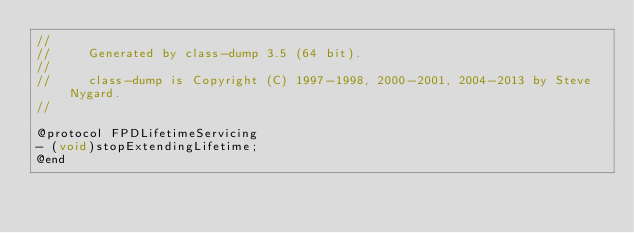Convert code to text. <code><loc_0><loc_0><loc_500><loc_500><_C_>//
//     Generated by class-dump 3.5 (64 bit).
//
//     class-dump is Copyright (C) 1997-1998, 2000-2001, 2004-2013 by Steve Nygard.
//

@protocol FPDLifetimeServicing
- (void)stopExtendingLifetime;
@end

</code> 